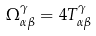Convert formula to latex. <formula><loc_0><loc_0><loc_500><loc_500>\Omega _ { \alpha \beta } ^ { \gamma } = 4 T _ { \alpha \beta } ^ { \gamma }</formula> 